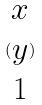<formula> <loc_0><loc_0><loc_500><loc_500>( \begin{matrix} x \\ y \\ 1 \end{matrix} )</formula> 